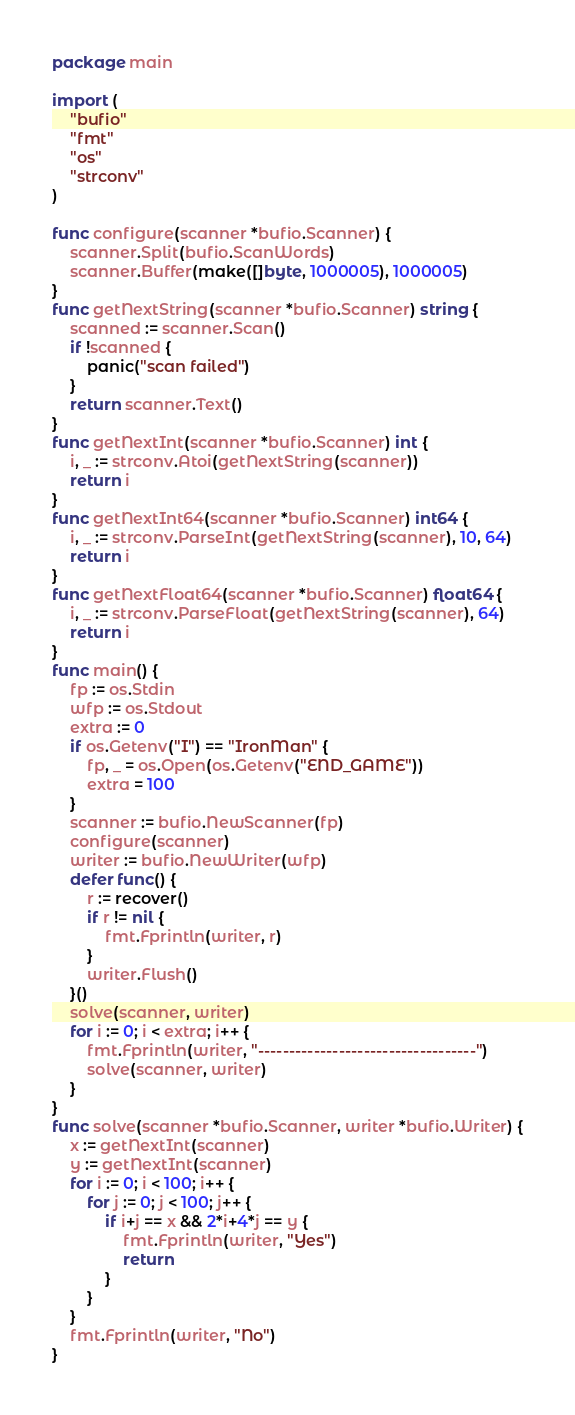<code> <loc_0><loc_0><loc_500><loc_500><_Go_>package main

import (
	"bufio"
	"fmt"
	"os"
	"strconv"
)

func configure(scanner *bufio.Scanner) {
	scanner.Split(bufio.ScanWords)
	scanner.Buffer(make([]byte, 1000005), 1000005)
}
func getNextString(scanner *bufio.Scanner) string {
	scanned := scanner.Scan()
	if !scanned {
		panic("scan failed")
	}
	return scanner.Text()
}
func getNextInt(scanner *bufio.Scanner) int {
	i, _ := strconv.Atoi(getNextString(scanner))
	return i
}
func getNextInt64(scanner *bufio.Scanner) int64 {
	i, _ := strconv.ParseInt(getNextString(scanner), 10, 64)
	return i
}
func getNextFloat64(scanner *bufio.Scanner) float64 {
	i, _ := strconv.ParseFloat(getNextString(scanner), 64)
	return i
}
func main() {
	fp := os.Stdin
	wfp := os.Stdout
	extra := 0
	if os.Getenv("I") == "IronMan" {
		fp, _ = os.Open(os.Getenv("END_GAME"))
		extra = 100
	}
	scanner := bufio.NewScanner(fp)
	configure(scanner)
	writer := bufio.NewWriter(wfp)
	defer func() {
		r := recover()
		if r != nil {
			fmt.Fprintln(writer, r)
		}
		writer.Flush()
	}()
	solve(scanner, writer)
	for i := 0; i < extra; i++ {
		fmt.Fprintln(writer, "-----------------------------------")
		solve(scanner, writer)
	}
}
func solve(scanner *bufio.Scanner, writer *bufio.Writer) {
	x := getNextInt(scanner)
	y := getNextInt(scanner)
	for i := 0; i < 100; i++ {
		for j := 0; j < 100; j++ {
			if i+j == x && 2*i+4*j == y {
				fmt.Fprintln(writer, "Yes")
				return
			}
		}
	}
	fmt.Fprintln(writer, "No")
}
</code> 